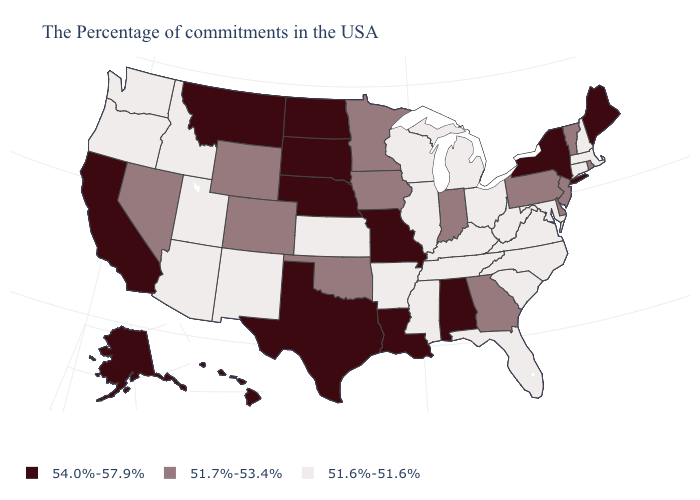Which states have the lowest value in the South?
Short answer required. Maryland, Virginia, North Carolina, South Carolina, West Virginia, Florida, Kentucky, Tennessee, Mississippi, Arkansas. What is the value of Virginia?
Quick response, please. 51.6%-51.6%. Does Virginia have the lowest value in the South?
Concise answer only. Yes. Which states have the lowest value in the South?
Short answer required. Maryland, Virginia, North Carolina, South Carolina, West Virginia, Florida, Kentucky, Tennessee, Mississippi, Arkansas. Among the states that border Idaho , which have the lowest value?
Concise answer only. Utah, Washington, Oregon. What is the value of Oklahoma?
Write a very short answer. 51.7%-53.4%. Name the states that have a value in the range 51.6%-51.6%?
Concise answer only. Massachusetts, New Hampshire, Connecticut, Maryland, Virginia, North Carolina, South Carolina, West Virginia, Ohio, Florida, Michigan, Kentucky, Tennessee, Wisconsin, Illinois, Mississippi, Arkansas, Kansas, New Mexico, Utah, Arizona, Idaho, Washington, Oregon. How many symbols are there in the legend?
Write a very short answer. 3. Does the first symbol in the legend represent the smallest category?
Keep it brief. No. What is the lowest value in the Northeast?
Quick response, please. 51.6%-51.6%. How many symbols are there in the legend?
Write a very short answer. 3. What is the value of Nebraska?
Give a very brief answer. 54.0%-57.9%. Name the states that have a value in the range 51.6%-51.6%?
Short answer required. Massachusetts, New Hampshire, Connecticut, Maryland, Virginia, North Carolina, South Carolina, West Virginia, Ohio, Florida, Michigan, Kentucky, Tennessee, Wisconsin, Illinois, Mississippi, Arkansas, Kansas, New Mexico, Utah, Arizona, Idaho, Washington, Oregon. What is the value of Massachusetts?
Give a very brief answer. 51.6%-51.6%. Name the states that have a value in the range 51.6%-51.6%?
Answer briefly. Massachusetts, New Hampshire, Connecticut, Maryland, Virginia, North Carolina, South Carolina, West Virginia, Ohio, Florida, Michigan, Kentucky, Tennessee, Wisconsin, Illinois, Mississippi, Arkansas, Kansas, New Mexico, Utah, Arizona, Idaho, Washington, Oregon. 